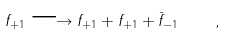<formula> <loc_0><loc_0><loc_500><loc_500>f _ { + 1 } \longrightarrow f _ { + 1 } + f _ { + 1 } + \bar { f } _ { - 1 } \quad ,</formula> 